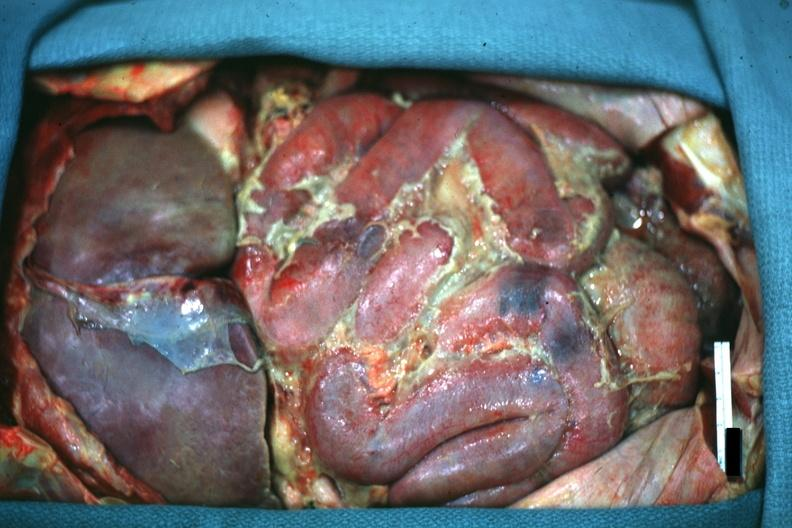what is present?
Answer the question using a single word or phrase. Acute peritonitis 